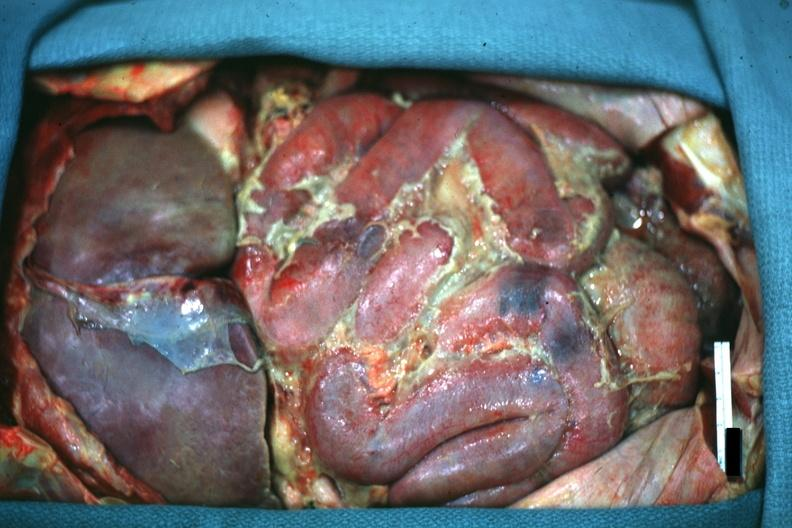what is present?
Answer the question using a single word or phrase. Acute peritonitis 